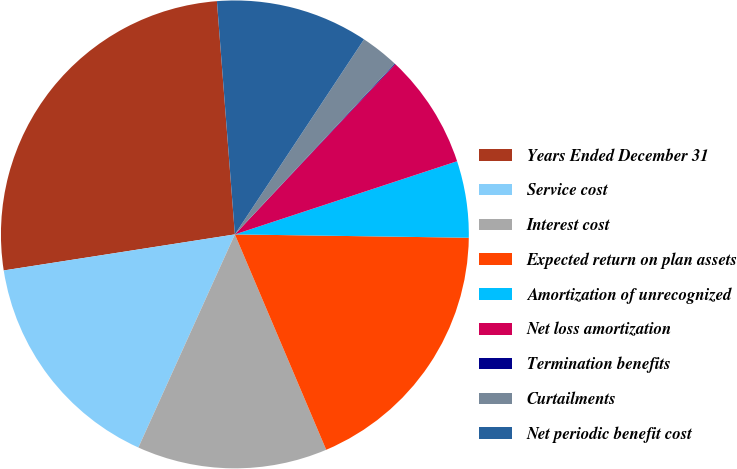<chart> <loc_0><loc_0><loc_500><loc_500><pie_chart><fcel>Years Ended December 31<fcel>Service cost<fcel>Interest cost<fcel>Expected return on plan assets<fcel>Amortization of unrecognized<fcel>Net loss amortization<fcel>Termination benefits<fcel>Curtailments<fcel>Net periodic benefit cost<nl><fcel>26.24%<fcel>15.77%<fcel>13.15%<fcel>18.39%<fcel>5.29%<fcel>7.91%<fcel>0.05%<fcel>2.67%<fcel>10.53%<nl></chart> 